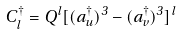Convert formula to latex. <formula><loc_0><loc_0><loc_500><loc_500>C _ { l } ^ { \dagger } = Q ^ { l } [ ( a _ { u } ^ { \dagger } ) ^ { 3 } - ( a _ { v } ^ { \dagger } ) ^ { 3 } ] ^ { l }</formula> 